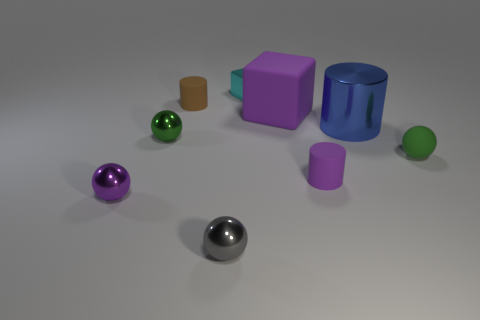Subtract all cylinders. How many objects are left? 6 Add 4 gray metallic balls. How many gray metallic balls exist? 5 Subtract 0 red blocks. How many objects are left? 9 Subtract all yellow cylinders. Subtract all tiny shiny spheres. How many objects are left? 6 Add 9 purple metal spheres. How many purple metal spheres are left? 10 